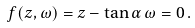<formula> <loc_0><loc_0><loc_500><loc_500>f ( z , \omega ) = z - \tan \alpha \, \omega = 0 \, .</formula> 